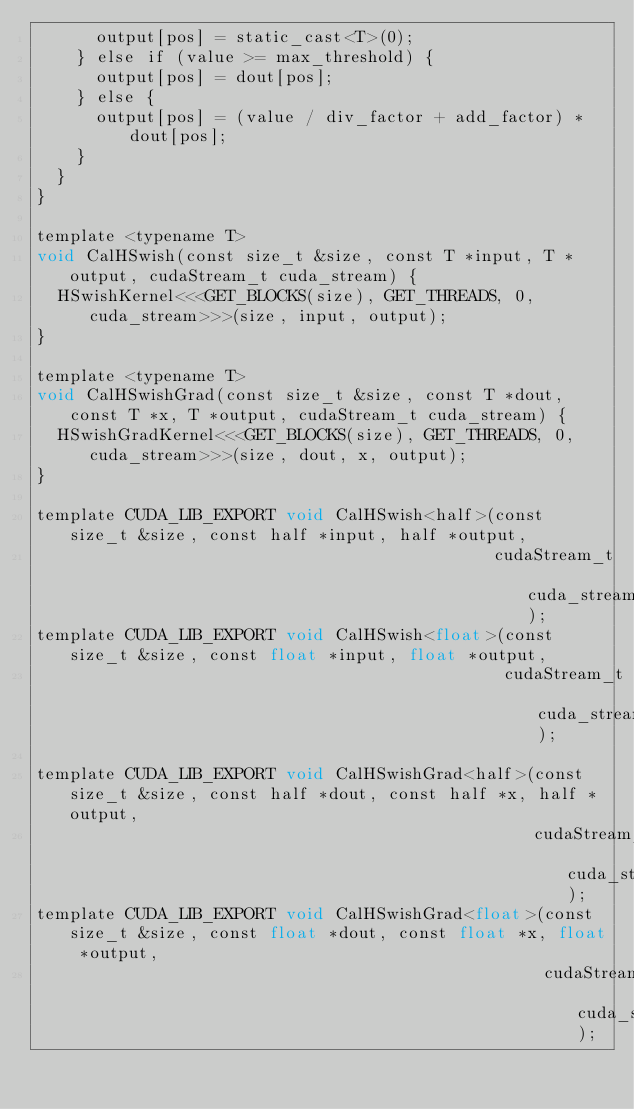<code> <loc_0><loc_0><loc_500><loc_500><_Cuda_>      output[pos] = static_cast<T>(0);
    } else if (value >= max_threshold) {
      output[pos] = dout[pos];
    } else {
      output[pos] = (value / div_factor + add_factor) * dout[pos];
    }
  }
}

template <typename T>
void CalHSwish(const size_t &size, const T *input, T *output, cudaStream_t cuda_stream) {
  HSwishKernel<<<GET_BLOCKS(size), GET_THREADS, 0, cuda_stream>>>(size, input, output);
}

template <typename T>
void CalHSwishGrad(const size_t &size, const T *dout, const T *x, T *output, cudaStream_t cuda_stream) {
  HSwishGradKernel<<<GET_BLOCKS(size), GET_THREADS, 0, cuda_stream>>>(size, dout, x, output);
}

template CUDA_LIB_EXPORT void CalHSwish<half>(const size_t &size, const half *input, half *output,
                                              cudaStream_t cuda_stream);
template CUDA_LIB_EXPORT void CalHSwish<float>(const size_t &size, const float *input, float *output,
                                               cudaStream_t cuda_stream);

template CUDA_LIB_EXPORT void CalHSwishGrad<half>(const size_t &size, const half *dout, const half *x, half *output,
                                                  cudaStream_t cuda_stream);
template CUDA_LIB_EXPORT void CalHSwishGrad<float>(const size_t &size, const float *dout, const float *x, float *output,
                                                   cudaStream_t cuda_stream);
</code> 